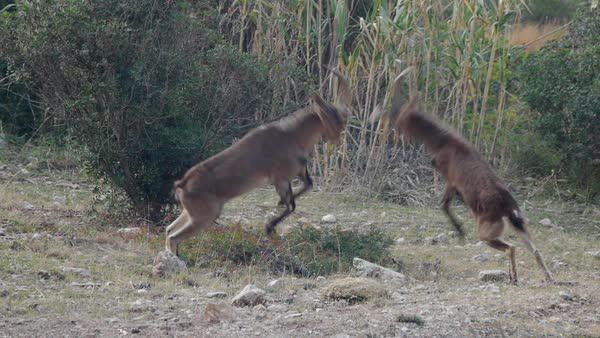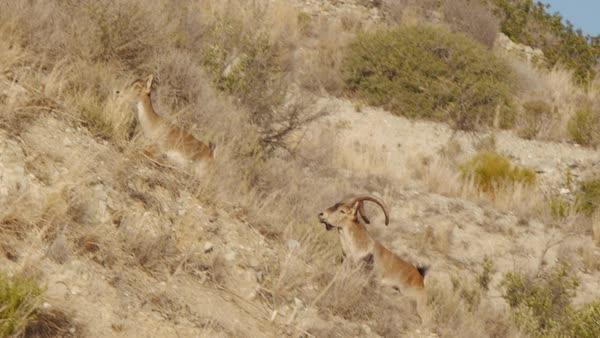The first image is the image on the left, the second image is the image on the right. For the images displayed, is the sentence "The animals in the image on the right are on a snowy rocky cliff." factually correct? Answer yes or no. No. The first image is the image on the left, the second image is the image on the right. For the images displayed, is the sentence "An image shows two hooved animals on a rocky mountainside with patches of white snow." factually correct? Answer yes or no. No. 